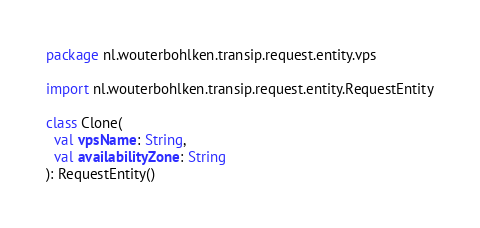Convert code to text. <code><loc_0><loc_0><loc_500><loc_500><_Kotlin_>package nl.wouterbohlken.transip.request.entity.vps

import nl.wouterbohlken.transip.request.entity.RequestEntity

class Clone(
  val vpsName: String,
  val availabilityZone: String
): RequestEntity()</code> 